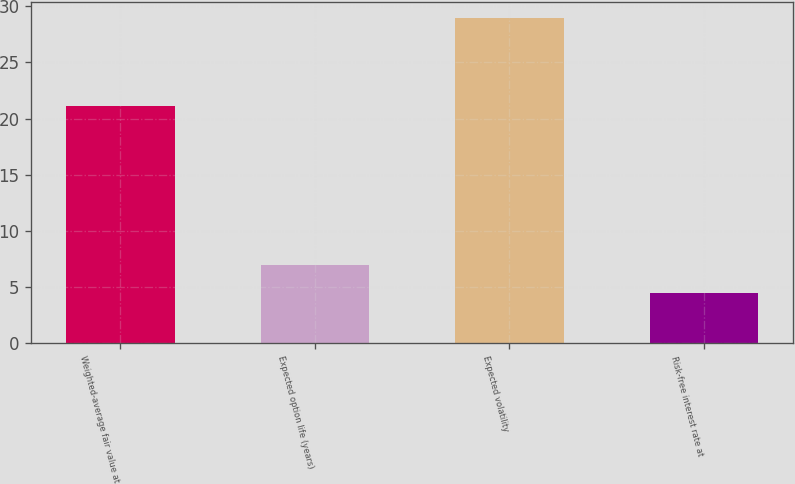Convert chart to OTSL. <chart><loc_0><loc_0><loc_500><loc_500><bar_chart><fcel>Weighted-average fair value at<fcel>Expected option life (years)<fcel>Expected volatility<fcel>Risk-free interest rate at<nl><fcel>21.07<fcel>6.94<fcel>28.9<fcel>4.5<nl></chart> 